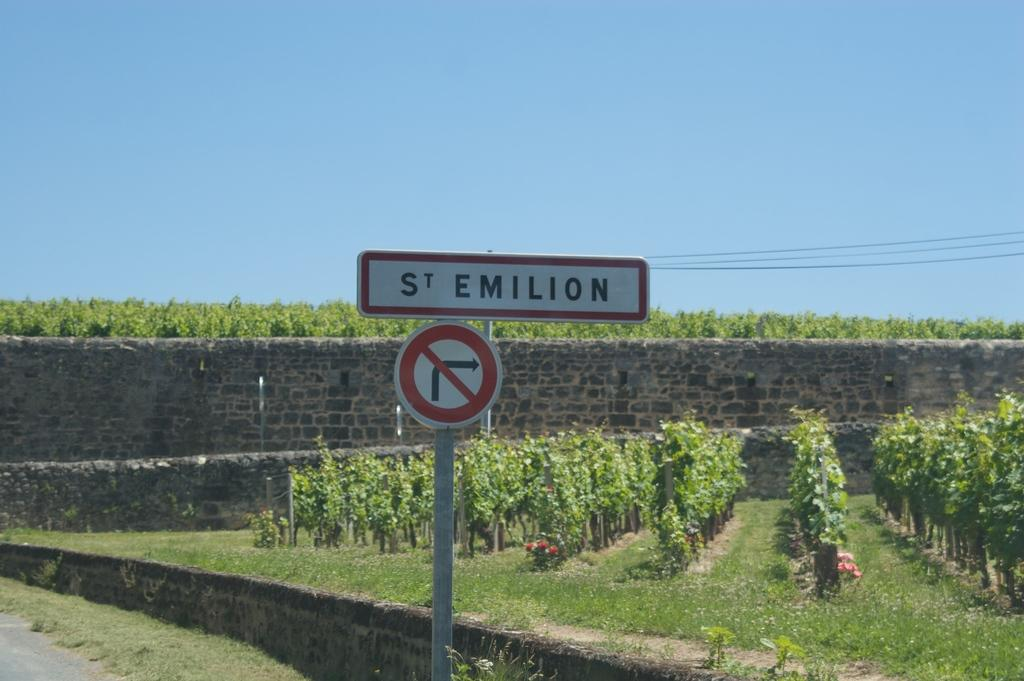What type of vegetation can be seen in the image? There are plants, trees, and grass in the image. Are there any flowers present in the image? Yes, there are flowers in the image. What type of structure is visible in the image? There is a wall in the image. What can be seen in the sky in the image? The sky is visible in the image. Reasoning: Let'ing: Let's think step by step in order to produce the conversation. We start by identifying the various types of vegetation present in the image, including plants, trees, and grass. We then mention the presence of flowers, which adds to the overall description of the natural elements in the image. Next, we focus on the structural elements, noting the presence of a wall. Finally, we mention the sky, which is visible in the image and provides context for the overall setting. Absurd Question/Answer: What type of chalk is being used to write on the lunchroom wall in the image? There is no chalk or lunchroom present in the image. Can you see any guns in the image? No, there are no guns visible in the image. 